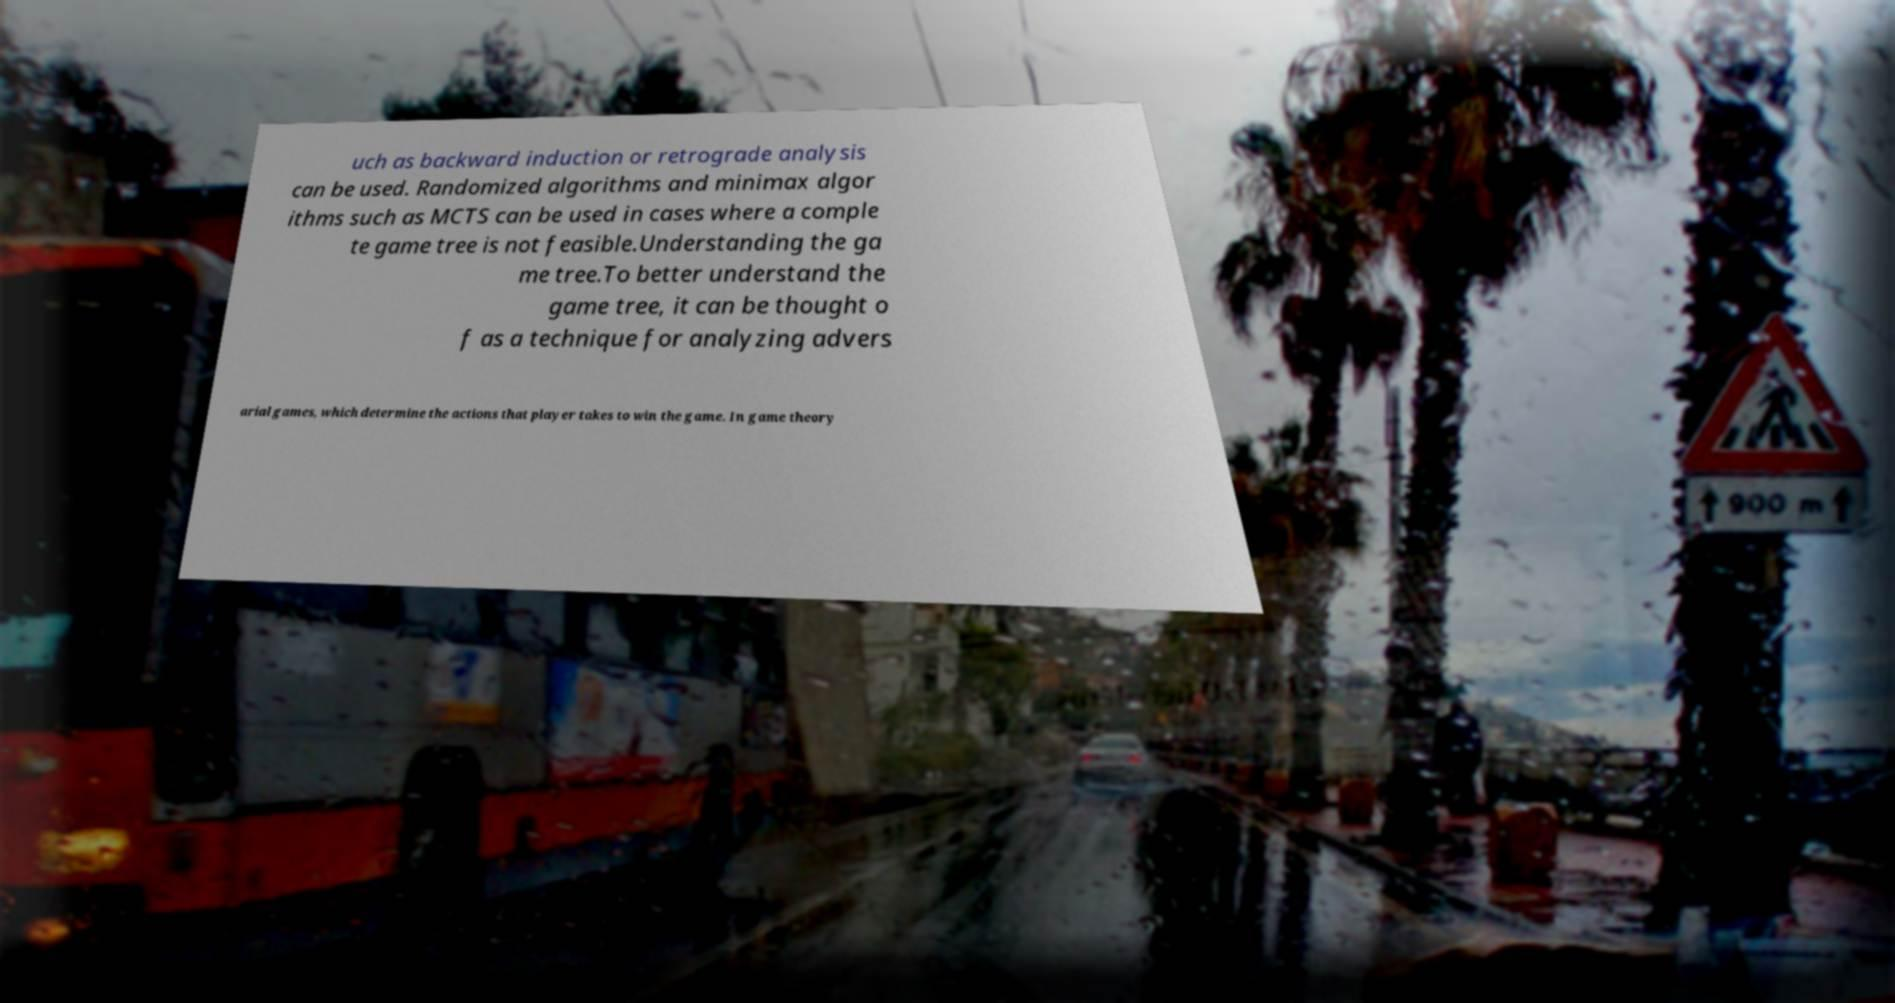Could you assist in decoding the text presented in this image and type it out clearly? uch as backward induction or retrograde analysis can be used. Randomized algorithms and minimax algor ithms such as MCTS can be used in cases where a comple te game tree is not feasible.Understanding the ga me tree.To better understand the game tree, it can be thought o f as a technique for analyzing advers arial games, which determine the actions that player takes to win the game. In game theory 